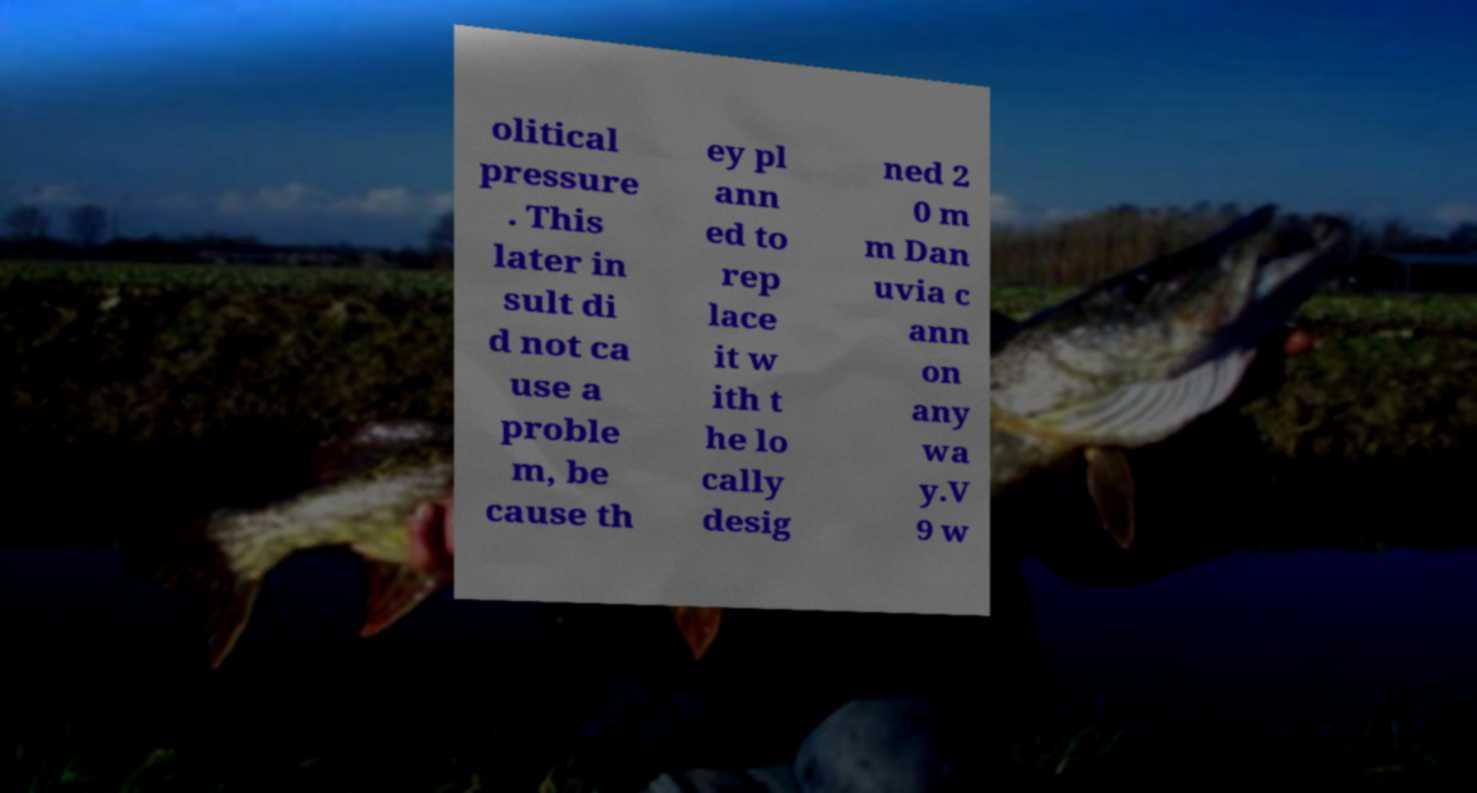There's text embedded in this image that I need extracted. Can you transcribe it verbatim? olitical pressure . This later in sult di d not ca use a proble m, be cause th ey pl ann ed to rep lace it w ith t he lo cally desig ned 2 0 m m Dan uvia c ann on any wa y.V 9 w 